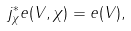<formula> <loc_0><loc_0><loc_500><loc_500>j ^ { * } _ { \chi } e ( V , \chi ) = e ( V ) ,</formula> 